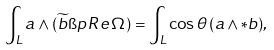<formula> <loc_0><loc_0><loc_500><loc_500>\int _ { L } a \wedge ( \widetilde { b } \i p \, R e \, \Omega ) = \int _ { L } \cos \theta \, ( a \wedge * b ) ,</formula> 